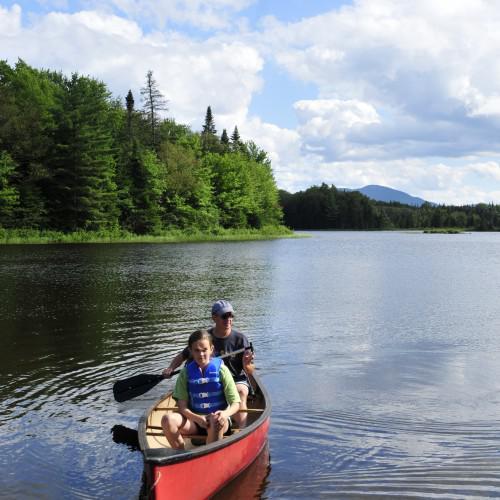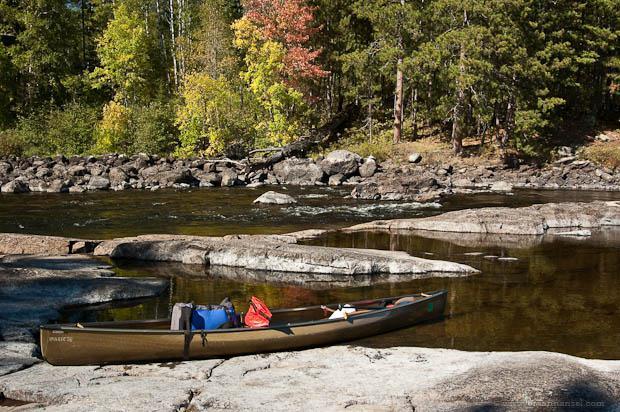The first image is the image on the left, the second image is the image on the right. For the images displayed, is the sentence "One image contains at least one red canoe on water, and the other contains at least one beige canoe." factually correct? Answer yes or no. Yes. The first image is the image on the left, the second image is the image on the right. Considering the images on both sides, is "There are no more than 4 canoeists." valid? Answer yes or no. Yes. 